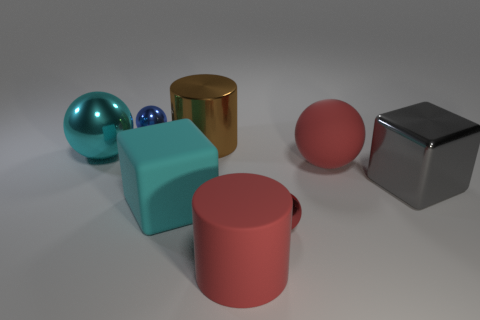How many matte things are either tiny blue balls or big gray cylinders?
Provide a succinct answer. 0. Do the matte ball and the large matte cylinder have the same color?
Provide a succinct answer. Yes. Is there anything else that is the same color as the rubber block?
Provide a short and direct response. Yes. There is a large red thing in front of the gray cube; is its shape the same as the matte thing left of the large red cylinder?
Provide a short and direct response. No. What number of objects are red things or tiny things behind the gray block?
Ensure brevity in your answer.  4. How many other objects are the same size as the rubber cylinder?
Your response must be concise. 5. Do the cylinder that is left of the matte cylinder and the red sphere that is in front of the metal block have the same material?
Make the answer very short. Yes. There is a small red metal thing; what number of tiny red objects are in front of it?
Your response must be concise. 0. How many red things are either metallic balls or large blocks?
Provide a short and direct response. 1. What material is the cyan block that is the same size as the gray block?
Your answer should be compact. Rubber. 